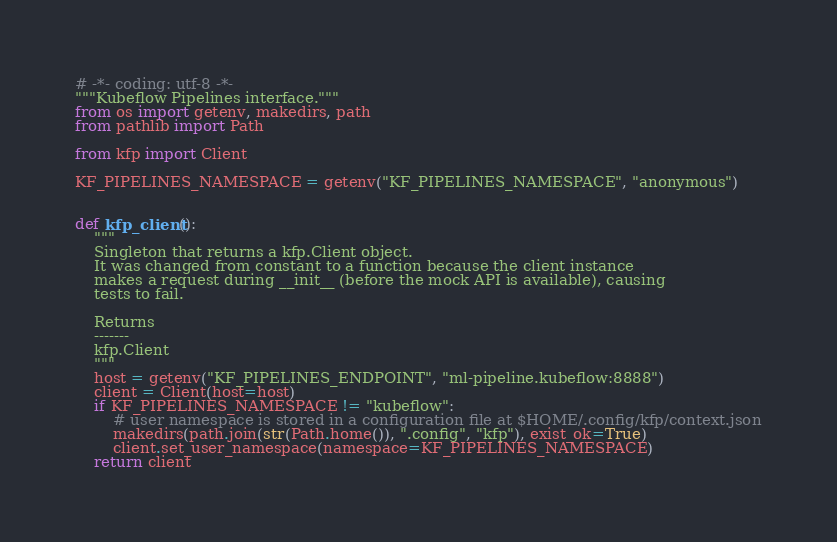<code> <loc_0><loc_0><loc_500><loc_500><_Python_># -*- coding: utf-8 -*-
"""Kubeflow Pipelines interface."""
from os import getenv, makedirs, path
from pathlib import Path

from kfp import Client

KF_PIPELINES_NAMESPACE = getenv("KF_PIPELINES_NAMESPACE", "anonymous")


def kfp_client():
    """
    Singleton that returns a kfp.Client object.
    It was changed from constant to a function because the client instance
    makes a request during __init__ (before the mock API is available), causing
    tests to fail.

    Returns
    -------
    kfp.Client
    """
    host = getenv("KF_PIPELINES_ENDPOINT", "ml-pipeline.kubeflow:8888")
    client = Client(host=host)
    if KF_PIPELINES_NAMESPACE != "kubeflow":
        # user namespace is stored in a configuration file at $HOME/.config/kfp/context.json
        makedirs(path.join(str(Path.home()), ".config", "kfp"), exist_ok=True)
        client.set_user_namespace(namespace=KF_PIPELINES_NAMESPACE)
    return client
</code> 